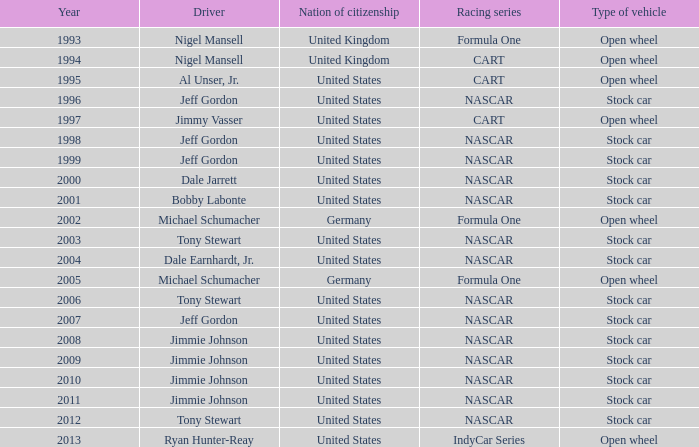What Nation of citizenship has a stock car vehicle with a year of 1999? United States. 